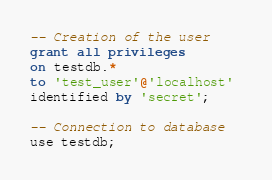Convert code to text. <code><loc_0><loc_0><loc_500><loc_500><_SQL_>-- Creation of the user
grant all privileges 
on testdb.* 
to 'test_user'@'localhost' 
identified by 'secret';

-- Connection to database
use testdb;
</code> 